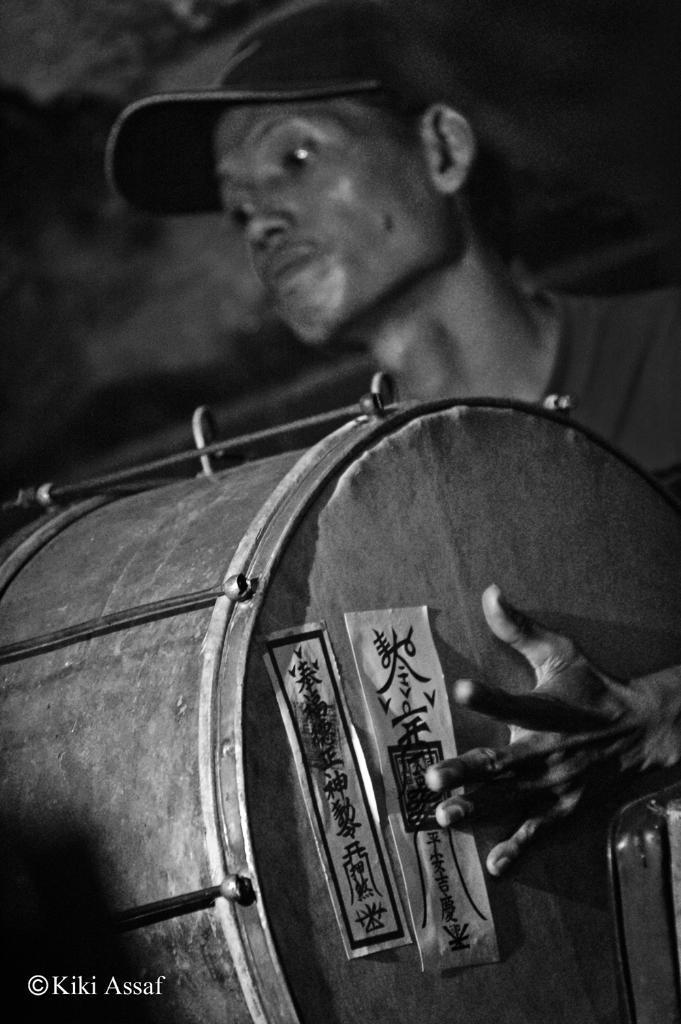Can you describe this image briefly? This picture shows a man who is wearing a cap, playing drum with his hands. 